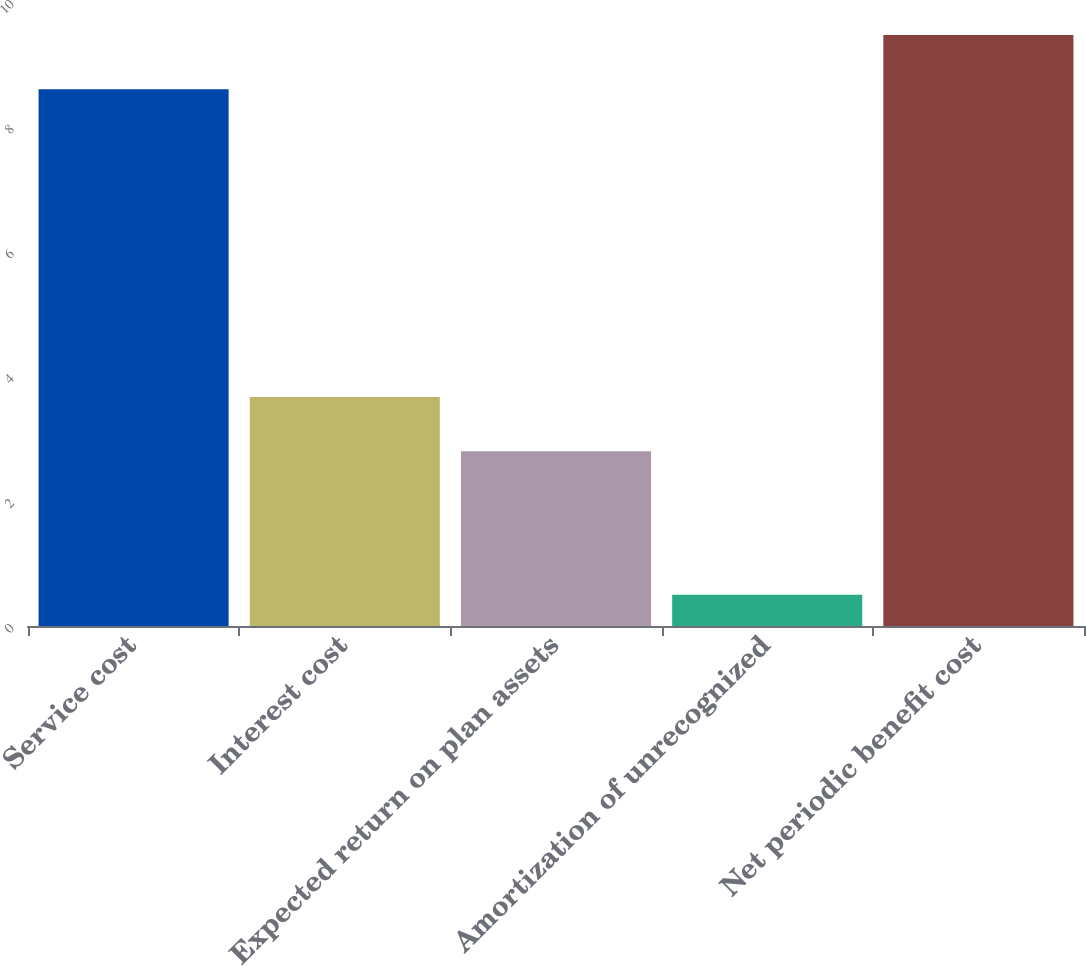<chart> <loc_0><loc_0><loc_500><loc_500><bar_chart><fcel>Service cost<fcel>Interest cost<fcel>Expected return on plan assets<fcel>Amortization of unrecognized<fcel>Net periodic benefit cost<nl><fcel>8.6<fcel>3.67<fcel>2.8<fcel>0.5<fcel>9.47<nl></chart> 